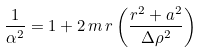<formula> <loc_0><loc_0><loc_500><loc_500>\frac { 1 } { \alpha ^ { 2 } } = 1 + 2 \, m \, r \left ( \frac { r ^ { 2 } + a ^ { 2 } } { \Delta \rho ^ { 2 } } \right )</formula> 